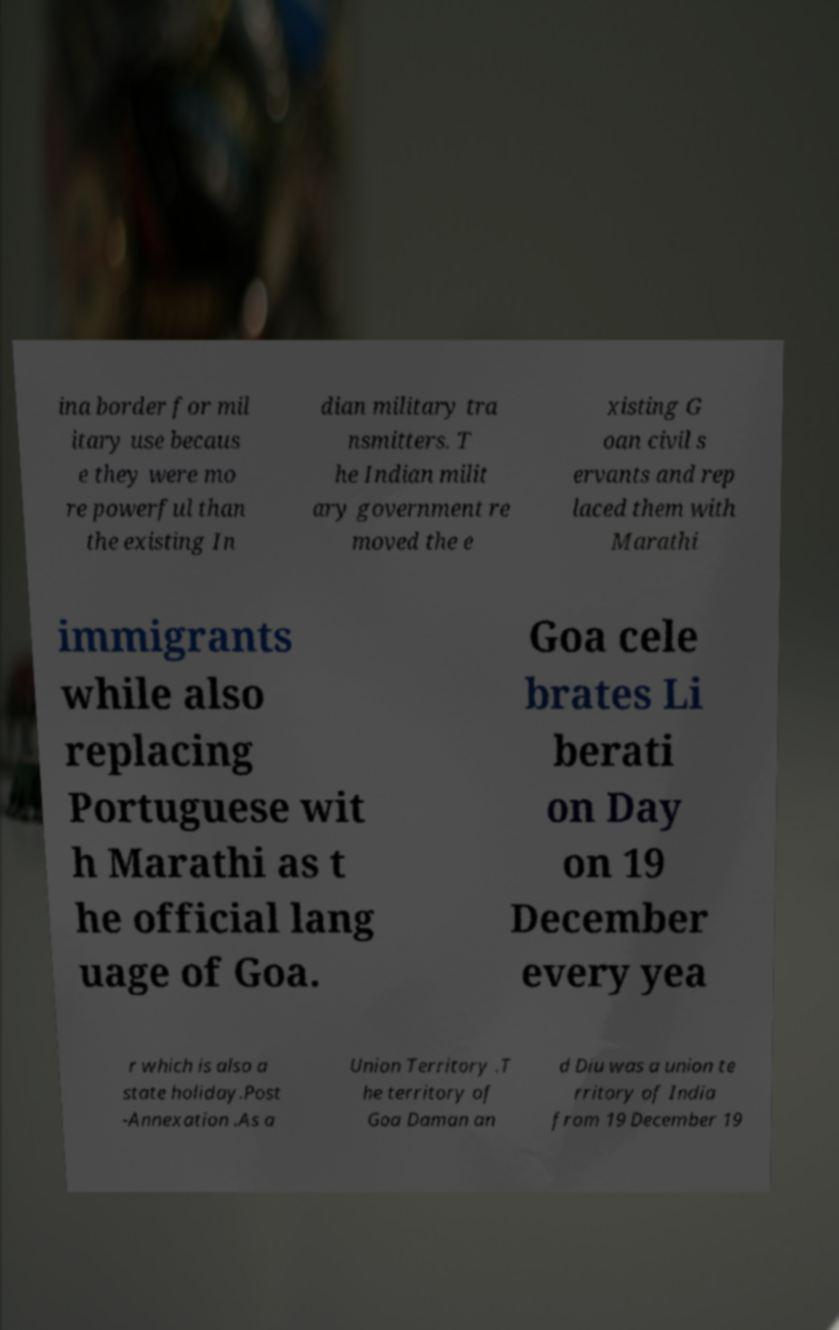I need the written content from this picture converted into text. Can you do that? ina border for mil itary use becaus e they were mo re powerful than the existing In dian military tra nsmitters. T he Indian milit ary government re moved the e xisting G oan civil s ervants and rep laced them with Marathi immigrants while also replacing Portuguese wit h Marathi as t he official lang uage of Goa. Goa cele brates Li berati on Day on 19 December every yea r which is also a state holiday.Post -Annexation .As a Union Territory .T he territory of Goa Daman an d Diu was a union te rritory of India from 19 December 19 